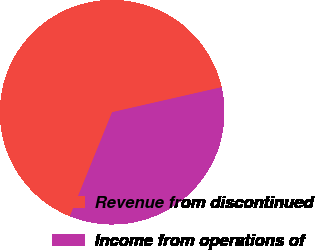<chart> <loc_0><loc_0><loc_500><loc_500><pie_chart><fcel>Revenue from discontinued<fcel>Income from operations of<nl><fcel>65.29%<fcel>34.71%<nl></chart> 